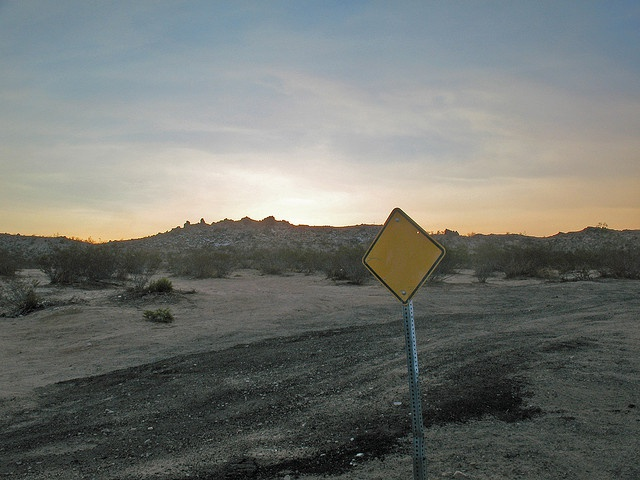Describe the objects in this image and their specific colors. I can see various objects in this image with different colors. 